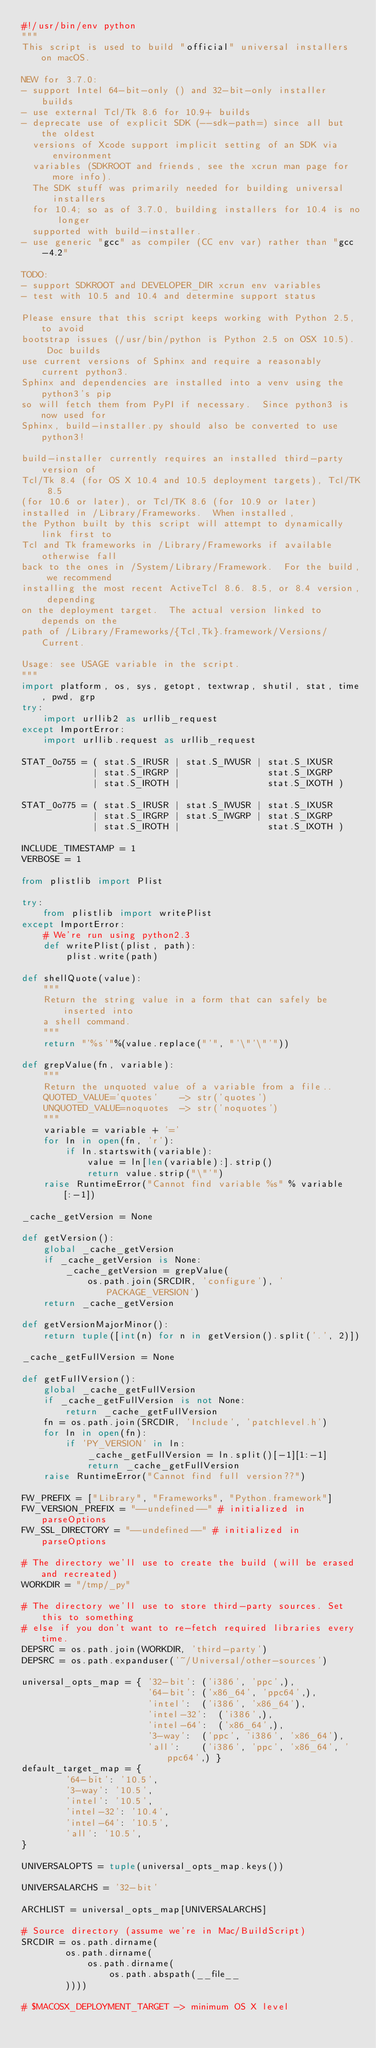Convert code to text. <code><loc_0><loc_0><loc_500><loc_500><_Python_>#!/usr/bin/env python
"""
This script is used to build "official" universal installers on macOS.

NEW for 3.7.0:
- support Intel 64-bit-only () and 32-bit-only installer builds
- use external Tcl/Tk 8.6 for 10.9+ builds
- deprecate use of explicit SDK (--sdk-path=) since all but the oldest
  versions of Xcode support implicit setting of an SDK via environment
  variables (SDKROOT and friends, see the xcrun man page for more info).
  The SDK stuff was primarily needed for building universal installers
  for 10.4; so as of 3.7.0, building installers for 10.4 is no longer
  supported with build-installer.
- use generic "gcc" as compiler (CC env var) rather than "gcc-4.2"

TODO:
- support SDKROOT and DEVELOPER_DIR xcrun env variables
- test with 10.5 and 10.4 and determine support status

Please ensure that this script keeps working with Python 2.5, to avoid
bootstrap issues (/usr/bin/python is Python 2.5 on OSX 10.5).  Doc builds
use current versions of Sphinx and require a reasonably current python3.
Sphinx and dependencies are installed into a venv using the python3's pip
so will fetch them from PyPI if necessary.  Since python3 is now used for
Sphinx, build-installer.py should also be converted to use python3!

build-installer currently requires an installed third-party version of
Tcl/Tk 8.4 (for OS X 10.4 and 10.5 deployment targets), Tcl/TK 8.5
(for 10.6 or later), or Tcl/TK 8.6 (for 10.9 or later)
installed in /Library/Frameworks.  When installed,
the Python built by this script will attempt to dynamically link first to
Tcl and Tk frameworks in /Library/Frameworks if available otherwise fall
back to the ones in /System/Library/Framework.  For the build, we recommend
installing the most recent ActiveTcl 8.6. 8.5, or 8.4 version, depending
on the deployment target.  The actual version linked to depends on the
path of /Library/Frameworks/{Tcl,Tk}.framework/Versions/Current.

Usage: see USAGE variable in the script.
"""
import platform, os, sys, getopt, textwrap, shutil, stat, time, pwd, grp
try:
    import urllib2 as urllib_request
except ImportError:
    import urllib.request as urllib_request

STAT_0o755 = ( stat.S_IRUSR | stat.S_IWUSR | stat.S_IXUSR
             | stat.S_IRGRP |                stat.S_IXGRP
             | stat.S_IROTH |                stat.S_IXOTH )

STAT_0o775 = ( stat.S_IRUSR | stat.S_IWUSR | stat.S_IXUSR
             | stat.S_IRGRP | stat.S_IWGRP | stat.S_IXGRP
             | stat.S_IROTH |                stat.S_IXOTH )

INCLUDE_TIMESTAMP = 1
VERBOSE = 1

from plistlib import Plist

try:
    from plistlib import writePlist
except ImportError:
    # We're run using python2.3
    def writePlist(plist, path):
        plist.write(path)

def shellQuote(value):
    """
    Return the string value in a form that can safely be inserted into
    a shell command.
    """
    return "'%s'"%(value.replace("'", "'\"'\"'"))

def grepValue(fn, variable):
    """
    Return the unquoted value of a variable from a file..
    QUOTED_VALUE='quotes'    -> str('quotes')
    UNQUOTED_VALUE=noquotes  -> str('noquotes')
    """
    variable = variable + '='
    for ln in open(fn, 'r'):
        if ln.startswith(variable):
            value = ln[len(variable):].strip()
            return value.strip("\"'")
    raise RuntimeError("Cannot find variable %s" % variable[:-1])

_cache_getVersion = None

def getVersion():
    global _cache_getVersion
    if _cache_getVersion is None:
        _cache_getVersion = grepValue(
            os.path.join(SRCDIR, 'configure'), 'PACKAGE_VERSION')
    return _cache_getVersion

def getVersionMajorMinor():
    return tuple([int(n) for n in getVersion().split('.', 2)])

_cache_getFullVersion = None

def getFullVersion():
    global _cache_getFullVersion
    if _cache_getFullVersion is not None:
        return _cache_getFullVersion
    fn = os.path.join(SRCDIR, 'Include', 'patchlevel.h')
    for ln in open(fn):
        if 'PY_VERSION' in ln:
            _cache_getFullVersion = ln.split()[-1][1:-1]
            return _cache_getFullVersion
    raise RuntimeError("Cannot find full version??")

FW_PREFIX = ["Library", "Frameworks", "Python.framework"]
FW_VERSION_PREFIX = "--undefined--" # initialized in parseOptions
FW_SSL_DIRECTORY = "--undefined--" # initialized in parseOptions

# The directory we'll use to create the build (will be erased and recreated)
WORKDIR = "/tmp/_py"

# The directory we'll use to store third-party sources. Set this to something
# else if you don't want to re-fetch required libraries every time.
DEPSRC = os.path.join(WORKDIR, 'third-party')
DEPSRC = os.path.expanduser('~/Universal/other-sources')

universal_opts_map = { '32-bit': ('i386', 'ppc',),
                       '64-bit': ('x86_64', 'ppc64',),
                       'intel':  ('i386', 'x86_64'),
                       'intel-32':  ('i386',),
                       'intel-64':  ('x86_64',),
                       '3-way':  ('ppc', 'i386', 'x86_64'),
                       'all':    ('i386', 'ppc', 'x86_64', 'ppc64',) }
default_target_map = {
        '64-bit': '10.5',
        '3-way': '10.5',
        'intel': '10.5',
        'intel-32': '10.4',
        'intel-64': '10.5',
        'all': '10.5',
}

UNIVERSALOPTS = tuple(universal_opts_map.keys())

UNIVERSALARCHS = '32-bit'

ARCHLIST = universal_opts_map[UNIVERSALARCHS]

# Source directory (assume we're in Mac/BuildScript)
SRCDIR = os.path.dirname(
        os.path.dirname(
            os.path.dirname(
                os.path.abspath(__file__
        ))))

# $MACOSX_DEPLOYMENT_TARGET -> minimum OS X level</code> 